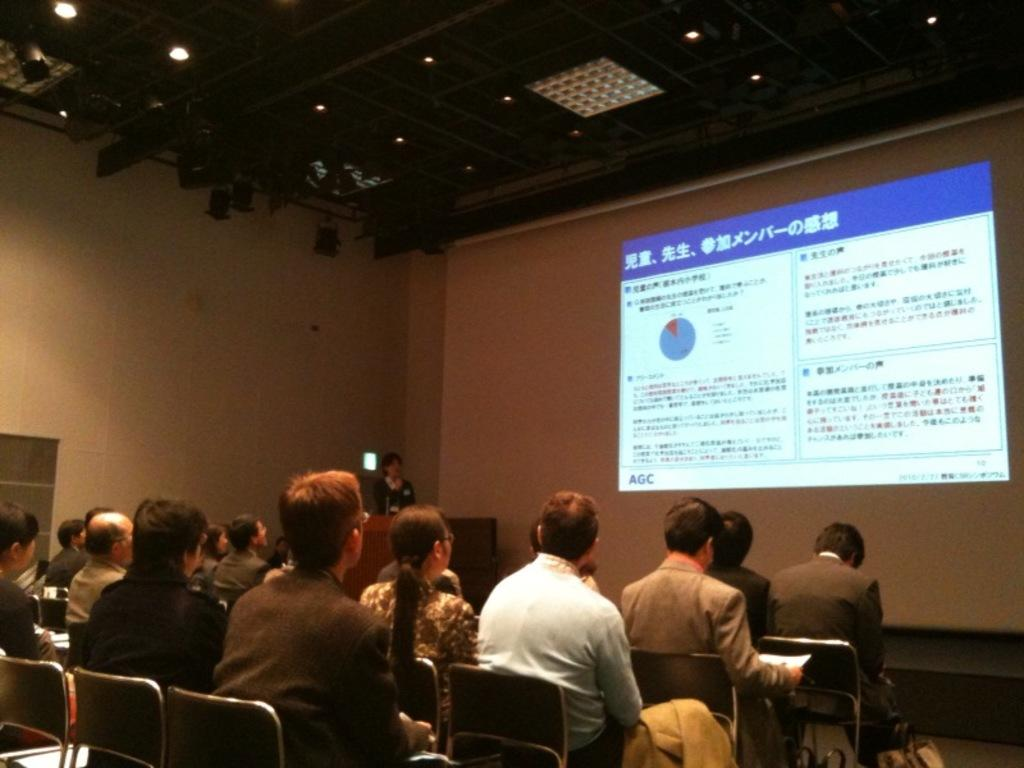What are the people in the image doing? The people in the image are sitting on chairs. What is in front of the chairs? There is a screen in front of the chairs. What can be seen on the ceiling in the image? There are lights on the ceiling in the image. What type of cub is sitting next to the person on the left chair? There is no cub present in the image; it only shows people sitting on chairs with a screen in front of them. 